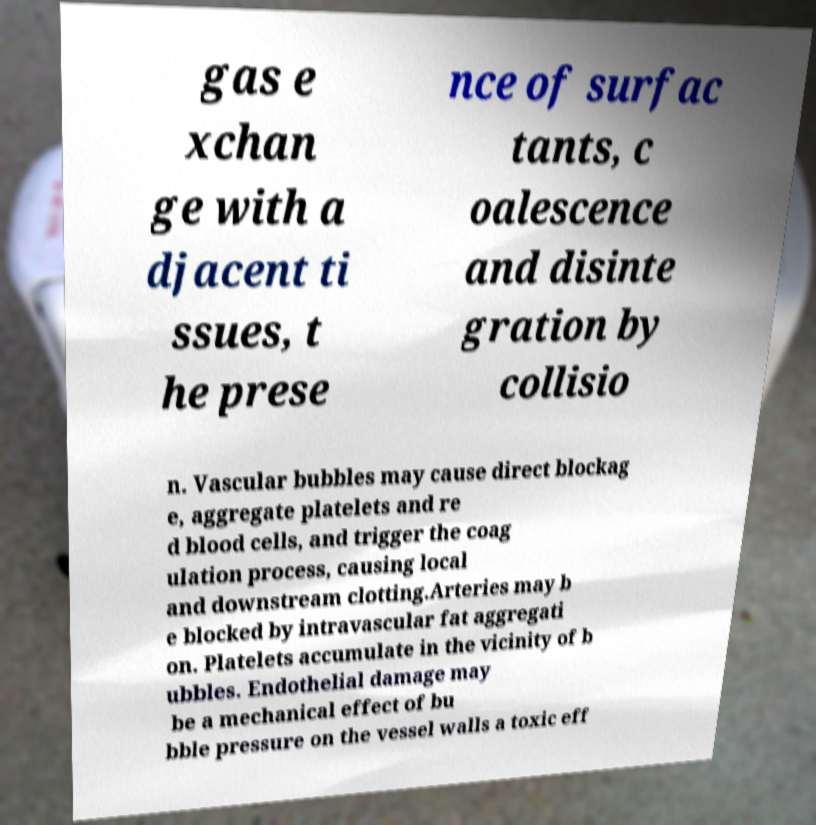Can you accurately transcribe the text from the provided image for me? gas e xchan ge with a djacent ti ssues, t he prese nce of surfac tants, c oalescence and disinte gration by collisio n. Vascular bubbles may cause direct blockag e, aggregate platelets and re d blood cells, and trigger the coag ulation process, causing local and downstream clotting.Arteries may b e blocked by intravascular fat aggregati on. Platelets accumulate in the vicinity of b ubbles. Endothelial damage may be a mechanical effect of bu bble pressure on the vessel walls a toxic eff 